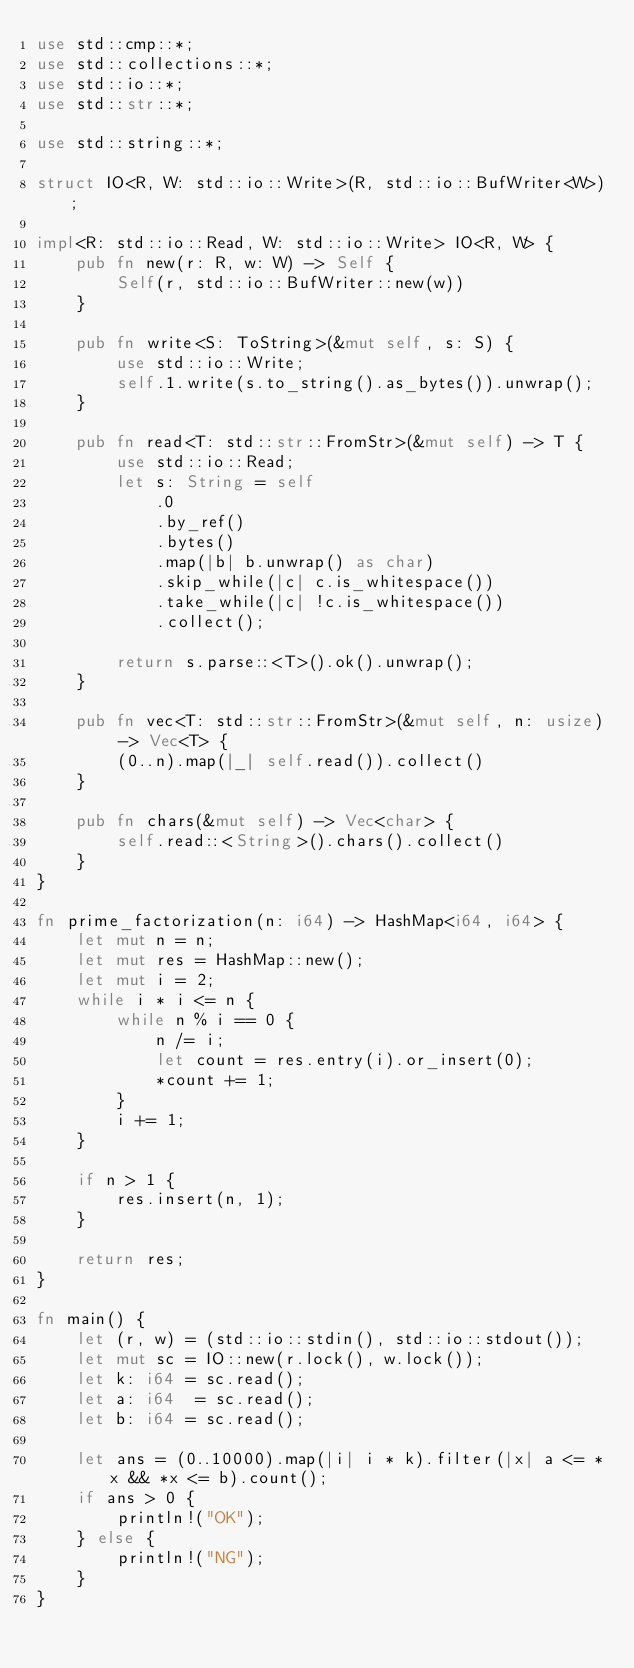Convert code to text. <code><loc_0><loc_0><loc_500><loc_500><_Rust_>use std::cmp::*;
use std::collections::*;
use std::io::*;
use std::str::*;

use std::string::*;

struct IO<R, W: std::io::Write>(R, std::io::BufWriter<W>);

impl<R: std::io::Read, W: std::io::Write> IO<R, W> {
    pub fn new(r: R, w: W) -> Self {
        Self(r, std::io::BufWriter::new(w))
    }

    pub fn write<S: ToString>(&mut self, s: S) {
        use std::io::Write;
        self.1.write(s.to_string().as_bytes()).unwrap();
    }

    pub fn read<T: std::str::FromStr>(&mut self) -> T {
        use std::io::Read;
        let s: String = self
            .0
            .by_ref()
            .bytes()
            .map(|b| b.unwrap() as char)
            .skip_while(|c| c.is_whitespace())
            .take_while(|c| !c.is_whitespace())
            .collect();

        return s.parse::<T>().ok().unwrap();
    }

    pub fn vec<T: std::str::FromStr>(&mut self, n: usize) -> Vec<T> {
        (0..n).map(|_| self.read()).collect()
    }

    pub fn chars(&mut self) -> Vec<char> {
        self.read::<String>().chars().collect()
    }
}

fn prime_factorization(n: i64) -> HashMap<i64, i64> {
    let mut n = n;
    let mut res = HashMap::new();
    let mut i = 2;
    while i * i <= n {
        while n % i == 0 {
            n /= i;
            let count = res.entry(i).or_insert(0);
            *count += 1;
        }
        i += 1;
    }

    if n > 1 {
        res.insert(n, 1);
    }

    return res;
}

fn main() {
    let (r, w) = (std::io::stdin(), std::io::stdout());
    let mut sc = IO::new(r.lock(), w.lock());
    let k: i64 = sc.read();
    let a: i64  = sc.read();
    let b: i64 = sc.read();

    let ans = (0..10000).map(|i| i * k).filter(|x| a <= *x && *x <= b).count();
    if ans > 0 {
        println!("OK");
    } else {
        println!("NG");
    }
}</code> 